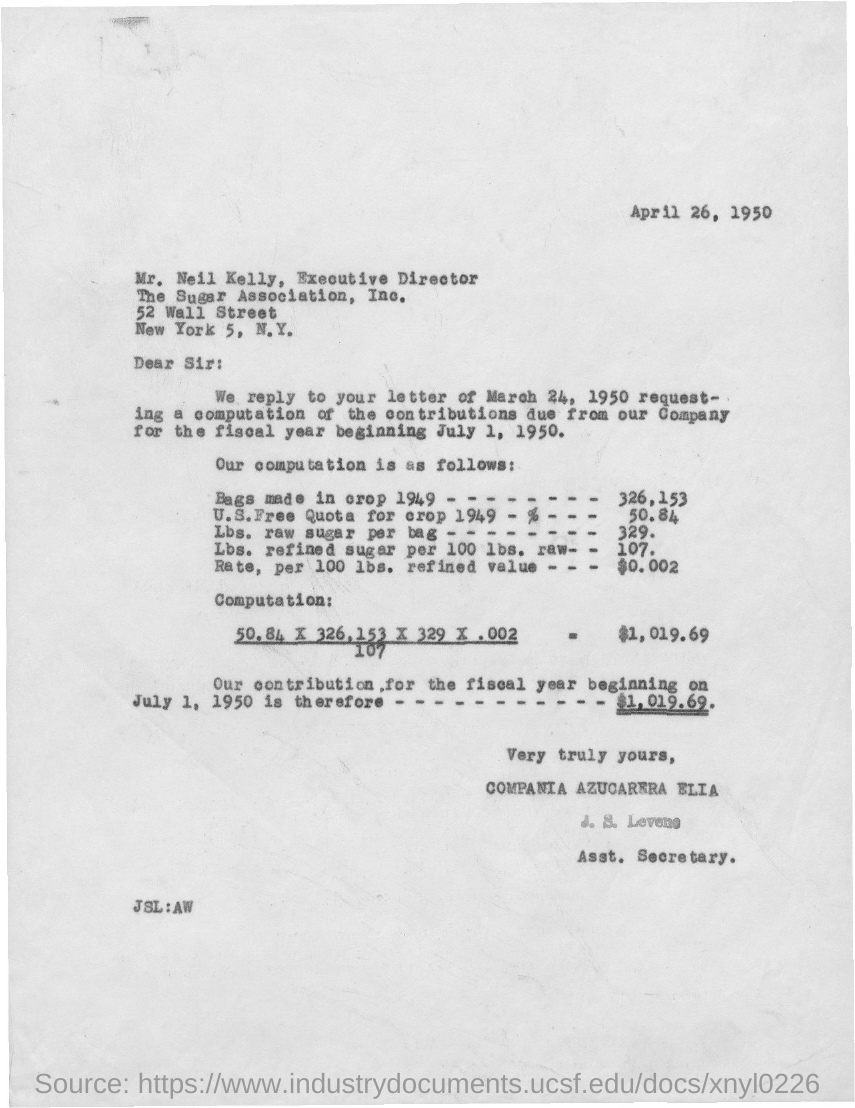What is the street address of the sugar association, inc.?
Make the answer very short. 52 Wall street. When is the letter dated ?
Your response must be concise. April 26, 1950. What is the position of mr. neil kelly ?
Provide a succinct answer. Executive Director. What is the title of j.s. levene ?
Make the answer very short. Asst. Secretary. 